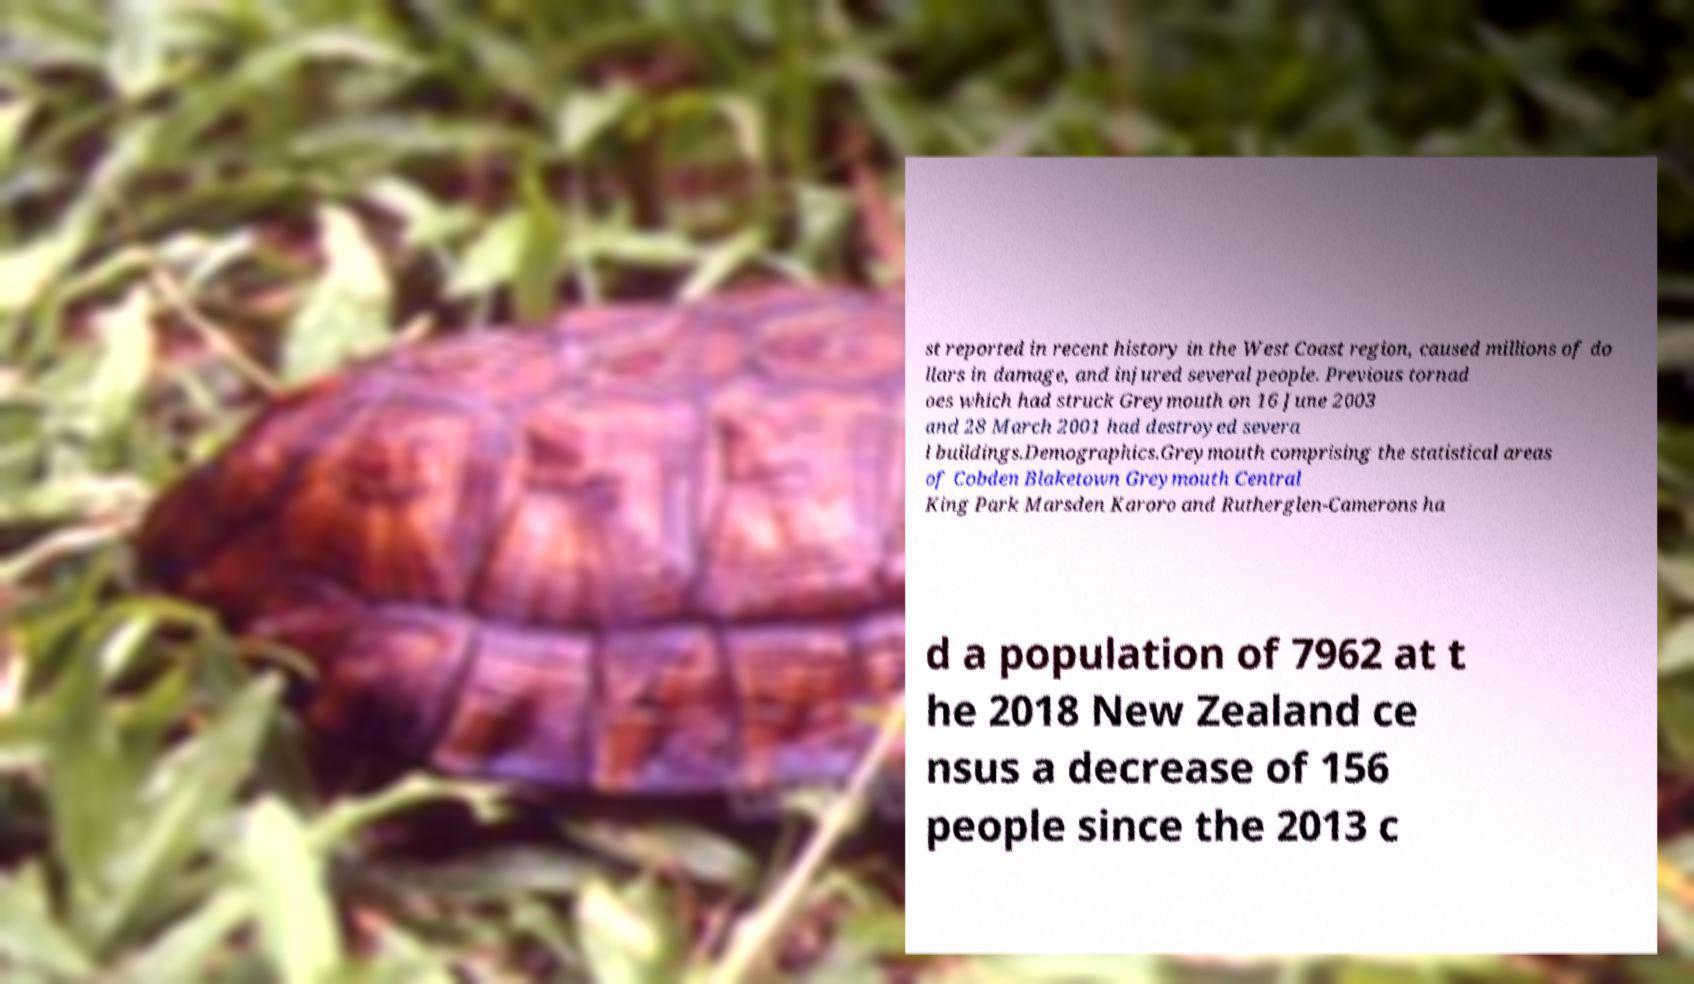Could you extract and type out the text from this image? st reported in recent history in the West Coast region, caused millions of do llars in damage, and injured several people. Previous tornad oes which had struck Greymouth on 16 June 2003 and 28 March 2001 had destroyed severa l buildings.Demographics.Greymouth comprising the statistical areas of Cobden Blaketown Greymouth Central King Park Marsden Karoro and Rutherglen-Camerons ha d a population of 7962 at t he 2018 New Zealand ce nsus a decrease of 156 people since the 2013 c 